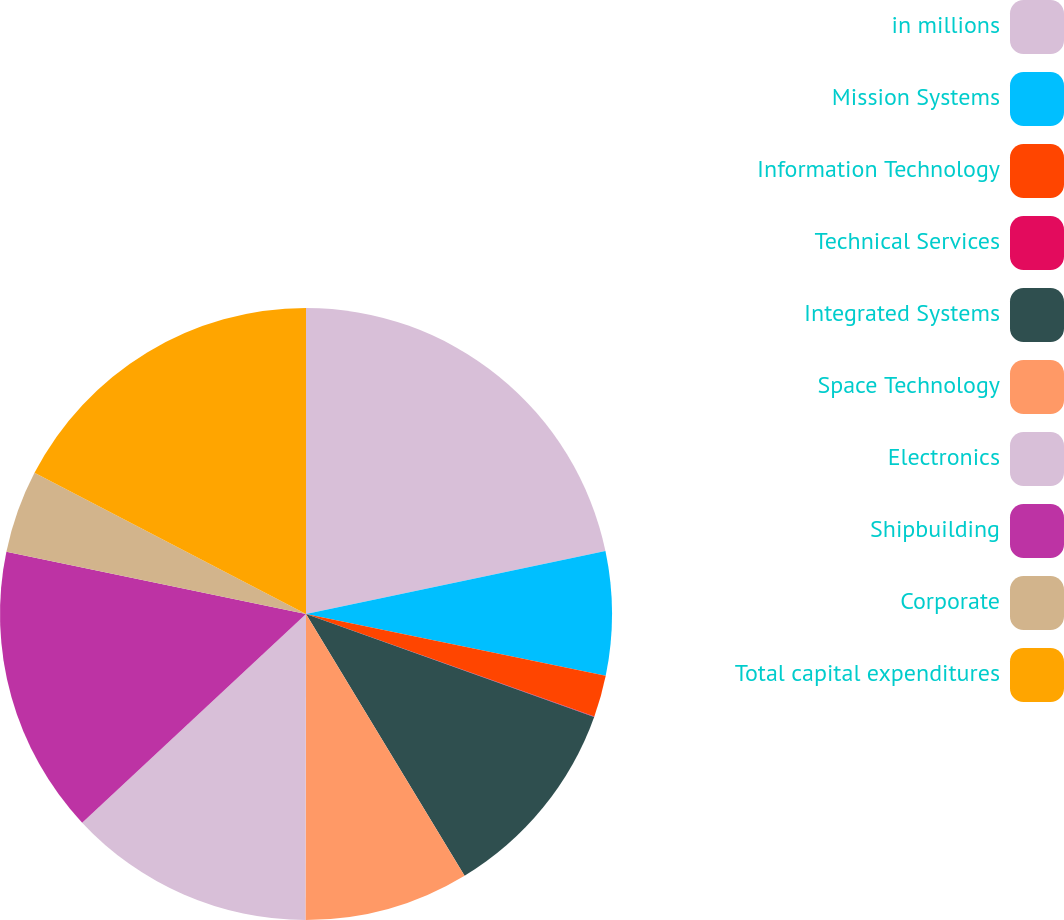<chart> <loc_0><loc_0><loc_500><loc_500><pie_chart><fcel>in millions<fcel>Mission Systems<fcel>Information Technology<fcel>Technical Services<fcel>Integrated Systems<fcel>Space Technology<fcel>Electronics<fcel>Shipbuilding<fcel>Corporate<fcel>Total capital expenditures<nl><fcel>21.7%<fcel>6.53%<fcel>2.2%<fcel>0.03%<fcel>10.87%<fcel>8.7%<fcel>13.03%<fcel>15.2%<fcel>4.37%<fcel>17.37%<nl></chart> 